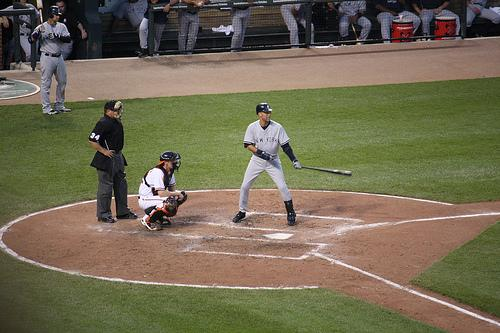Evaluate the image quality based on the clarity and visibility of the subjects and objects. The image quality is good, as there is clear visibility of subjects and objects with identifiable attributes such as clothing, equipment, and markings on the field. Explain the interaction between the baseball player preparing to hit and the catcher. The baseball player is holding a bat and preparing to hit the ball, while the catcher is crouched behind the home base, wearing protective gear, and ready to catch the pitch. What is the sentiment expressed by the image, given the setting and actions of the subjects? The sentiment expressed by the image is competitive and focused, as the subjects are involved in an active baseball game. Count the number of helmets with face protection visible in the image. There are 3 helmets with face protection visible in the image. Identify any objects present in the dugout area. A red cooler, white towel, and two dustbins are present in the dugout area. How many baseball players are there in the image, and what are they wearing? There are 3 baseball players in the image, wearing gray uniforms, black shirts, and helmets with face protection. Provide a brief summary of the objects and interactions observed in the image. In the image, there are baseball players, an umpire, and a catcher playing a game, several objects like bats, helmets, masks, and protective gear are visible, and the field and the dugout are marked with chalk lines. What type of sports event is taking place in the image, and who are the key participants involved? A baseball game is taking place with key participants being baseball players, an umpire, and a catcher. Describe the condition of the baseball field in the image. The baseball field has white chalk lines marking the boundaries, short green grass, and dirt areas where players are positioned, indicating an actively used and well-maintained field. List the things that people are wearing in the image. Gray uniforms, black shirts, helmets, masks, belts, shin protections, gloves, and black shoes are being worn by people in the image. What color is the face mask worn by a person in the image? White What type of helmet is the catcher wearing? Helmet with face protection Choose the correct description:  b) A person is wearing knee pads on his elbows. Are the players standing on grass or the field marked with white lines? White marked field Give a brief description of the interaction between the baseball player with a bat and the baseball catcher. The baseball player is preparing to hit, and the catcher is preparing to catch the pitch. Describe the grass visible in the photo. Short green grass Is there anything white in the scene except for the chalk lines on the field? White face mask, white towel, and white spot on the field List any accessories the baseball catcher is wearing. Facemask, helmet with face protection, shin protections Count the number of objects that are primarily black in color. 7 Can you find a player wearing a pink helmet with polka dots and waving to the crowd? There are several players with helmets, but none of them are described as pink with polka dots, nor are they waving to the crowd. Mention the dominant color and the logo or words on the uniform of the New York Yankees baseball player. Gray uniform with black words Which team's baseball player is in the scene? New York Yankees Is the baseball player wearing a red shirt and holding a green bat? There is a baseball player holding a bat, but the shirt is not red, and the bat is not green. State the color of the helmet on the player next to the on-deck circle. Blue Identify the color of the uniform worn by the man crouching in dirt. Gray List down the people and their roles or positions seen in the image. New York Yankees baseball player, baseball umpire, baseball catcher, player next to on deck circle Find the object alongside the umpire and describe its color. Black bag Describe the scene with people playing baseball in a poetic manner. Players ignite the field as a dance of skill unfolds, cheering hearts with each swing and catch. Do the players sitting and standing in a dugout have any visible emotions on their faces? No visible emotions detected Describe the crease on a player's pants in the image. Long and vertical crease Is there an elephant in the middle of the baseball field? No, it's not mentioned in the image. What is the color of the shirt worn by the baseball umpire? Black Is the umpire wearing a bright yellow uniform? The umpire is mentioned as being dressed all in black, not a bright yellow uniform. What is the sport being played by people in the image? Baseball Is there a catcher standing upright and not wearing any protective equipment? The catcher is described as crouching, and they are wearing a helmet with face protection, shin protections, and potentially gloves. 